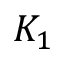<formula> <loc_0><loc_0><loc_500><loc_500>K _ { 1 }</formula> 